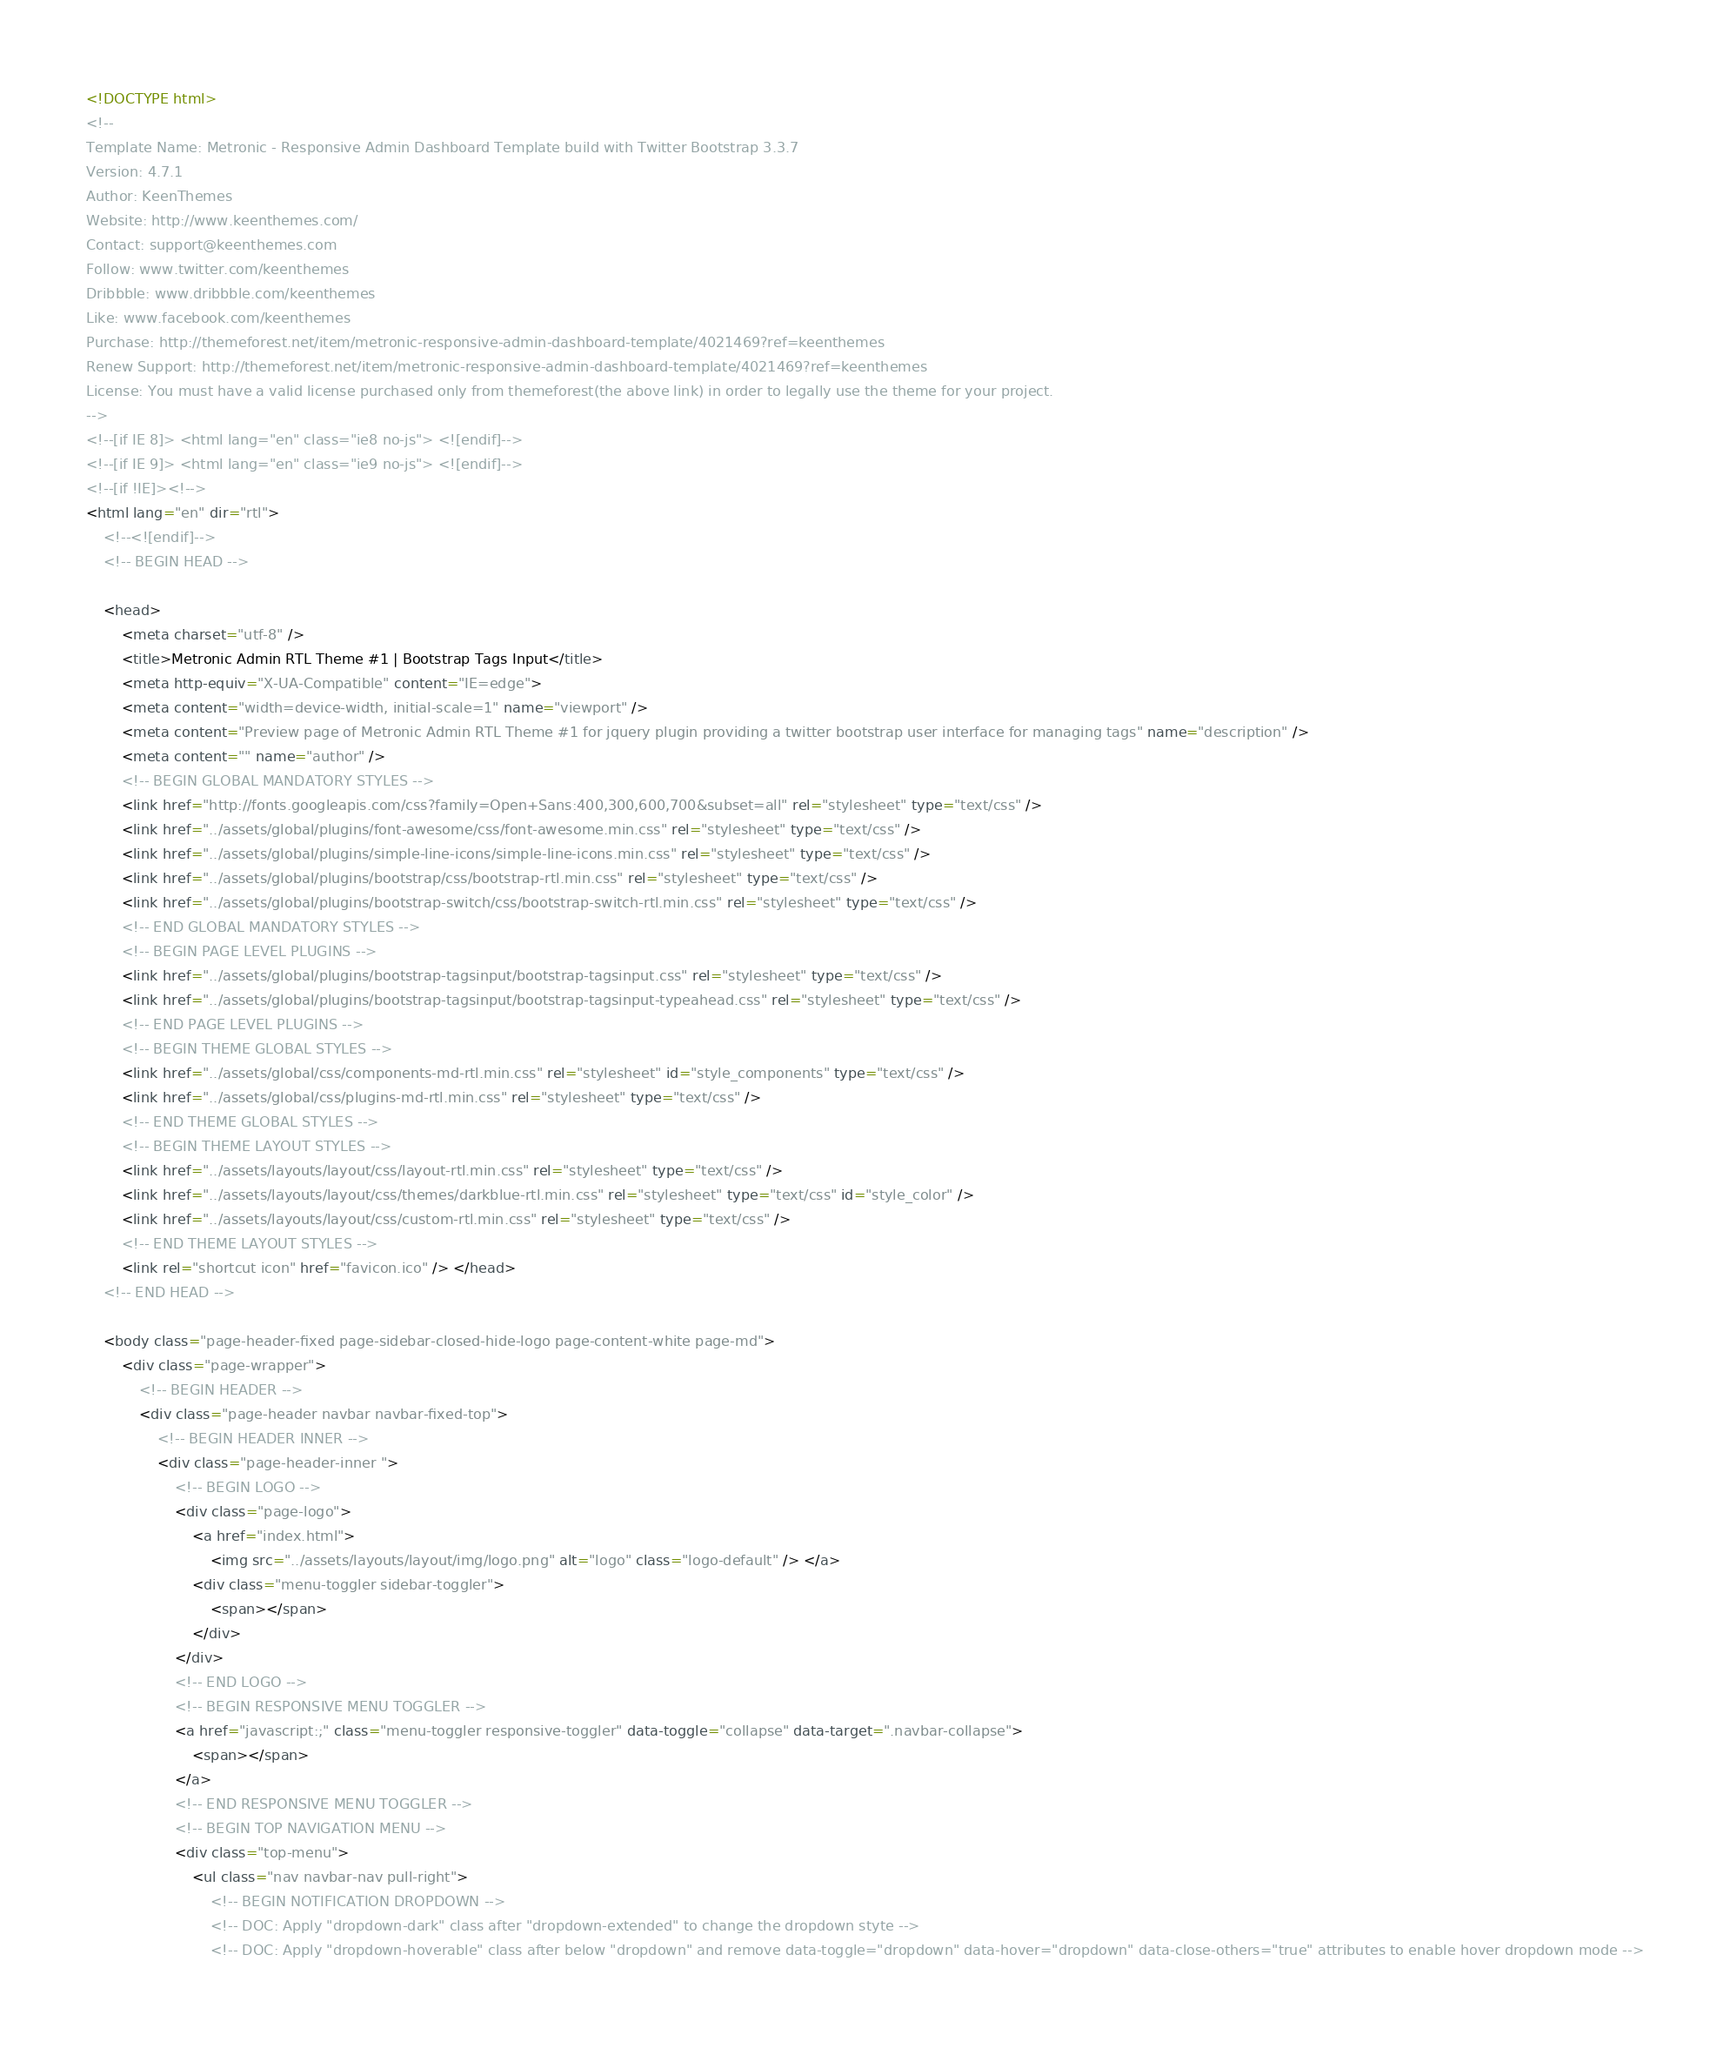Convert code to text. <code><loc_0><loc_0><loc_500><loc_500><_HTML_><!DOCTYPE html>
<!-- 
Template Name: Metronic - Responsive Admin Dashboard Template build with Twitter Bootstrap 3.3.7
Version: 4.7.1
Author: KeenThemes
Website: http://www.keenthemes.com/
Contact: support@keenthemes.com
Follow: www.twitter.com/keenthemes
Dribbble: www.dribbble.com/keenthemes
Like: www.facebook.com/keenthemes
Purchase: http://themeforest.net/item/metronic-responsive-admin-dashboard-template/4021469?ref=keenthemes
Renew Support: http://themeforest.net/item/metronic-responsive-admin-dashboard-template/4021469?ref=keenthemes
License: You must have a valid license purchased only from themeforest(the above link) in order to legally use the theme for your project.
-->
<!--[if IE 8]> <html lang="en" class="ie8 no-js"> <![endif]-->
<!--[if IE 9]> <html lang="en" class="ie9 no-js"> <![endif]-->
<!--[if !IE]><!-->
<html lang="en" dir="rtl">
    <!--<![endif]-->
    <!-- BEGIN HEAD -->

    <head>
        <meta charset="utf-8" />
        <title>Metronic Admin RTL Theme #1 | Bootstrap Tags Input</title>
        <meta http-equiv="X-UA-Compatible" content="IE=edge">
        <meta content="width=device-width, initial-scale=1" name="viewport" />
        <meta content="Preview page of Metronic Admin RTL Theme #1 for jquery plugin providing a twitter bootstrap user interface for managing tags" name="description" />
        <meta content="" name="author" />
        <!-- BEGIN GLOBAL MANDATORY STYLES -->
        <link href="http://fonts.googleapis.com/css?family=Open+Sans:400,300,600,700&subset=all" rel="stylesheet" type="text/css" />
        <link href="../assets/global/plugins/font-awesome/css/font-awesome.min.css" rel="stylesheet" type="text/css" />
        <link href="../assets/global/plugins/simple-line-icons/simple-line-icons.min.css" rel="stylesheet" type="text/css" />
        <link href="../assets/global/plugins/bootstrap/css/bootstrap-rtl.min.css" rel="stylesheet" type="text/css" />
        <link href="../assets/global/plugins/bootstrap-switch/css/bootstrap-switch-rtl.min.css" rel="stylesheet" type="text/css" />
        <!-- END GLOBAL MANDATORY STYLES -->
        <!-- BEGIN PAGE LEVEL PLUGINS -->
        <link href="../assets/global/plugins/bootstrap-tagsinput/bootstrap-tagsinput.css" rel="stylesheet" type="text/css" />
        <link href="../assets/global/plugins/bootstrap-tagsinput/bootstrap-tagsinput-typeahead.css" rel="stylesheet" type="text/css" />
        <!-- END PAGE LEVEL PLUGINS -->
        <!-- BEGIN THEME GLOBAL STYLES -->
        <link href="../assets/global/css/components-md-rtl.min.css" rel="stylesheet" id="style_components" type="text/css" />
        <link href="../assets/global/css/plugins-md-rtl.min.css" rel="stylesheet" type="text/css" />
        <!-- END THEME GLOBAL STYLES -->
        <!-- BEGIN THEME LAYOUT STYLES -->
        <link href="../assets/layouts/layout/css/layout-rtl.min.css" rel="stylesheet" type="text/css" />
        <link href="../assets/layouts/layout/css/themes/darkblue-rtl.min.css" rel="stylesheet" type="text/css" id="style_color" />
        <link href="../assets/layouts/layout/css/custom-rtl.min.css" rel="stylesheet" type="text/css" />
        <!-- END THEME LAYOUT STYLES -->
        <link rel="shortcut icon" href="favicon.ico" /> </head>
    <!-- END HEAD -->

    <body class="page-header-fixed page-sidebar-closed-hide-logo page-content-white page-md">
        <div class="page-wrapper">
            <!-- BEGIN HEADER -->
            <div class="page-header navbar navbar-fixed-top">
                <!-- BEGIN HEADER INNER -->
                <div class="page-header-inner ">
                    <!-- BEGIN LOGO -->
                    <div class="page-logo">
                        <a href="index.html">
                            <img src="../assets/layouts/layout/img/logo.png" alt="logo" class="logo-default" /> </a>
                        <div class="menu-toggler sidebar-toggler">
                            <span></span>
                        </div>
                    </div>
                    <!-- END LOGO -->
                    <!-- BEGIN RESPONSIVE MENU TOGGLER -->
                    <a href="javascript:;" class="menu-toggler responsive-toggler" data-toggle="collapse" data-target=".navbar-collapse">
                        <span></span>
                    </a>
                    <!-- END RESPONSIVE MENU TOGGLER -->
                    <!-- BEGIN TOP NAVIGATION MENU -->
                    <div class="top-menu">
                        <ul class="nav navbar-nav pull-right">
                            <!-- BEGIN NOTIFICATION DROPDOWN -->
                            <!-- DOC: Apply "dropdown-dark" class after "dropdown-extended" to change the dropdown styte -->
                            <!-- DOC: Apply "dropdown-hoverable" class after below "dropdown" and remove data-toggle="dropdown" data-hover="dropdown" data-close-others="true" attributes to enable hover dropdown mode --></code> 